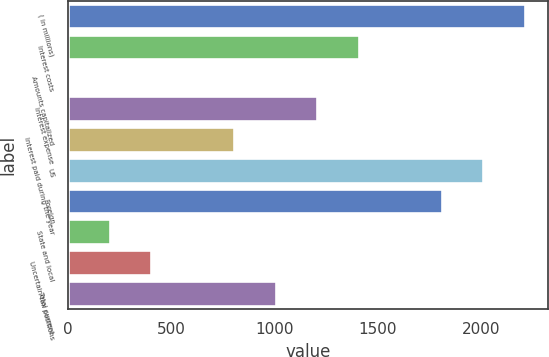<chart> <loc_0><loc_0><loc_500><loc_500><bar_chart><fcel>( in millions)<fcel>Interest costs<fcel>Amounts capitalized<fcel>Interest expense<fcel>Interest paid during the year<fcel>US<fcel>Foreign<fcel>State and local<fcel>Uncertain tax positions<fcel>Total current<nl><fcel>2210.71<fcel>1407.87<fcel>2.9<fcel>1207.16<fcel>805.74<fcel>2010<fcel>1809.29<fcel>203.61<fcel>404.32<fcel>1006.45<nl></chart> 